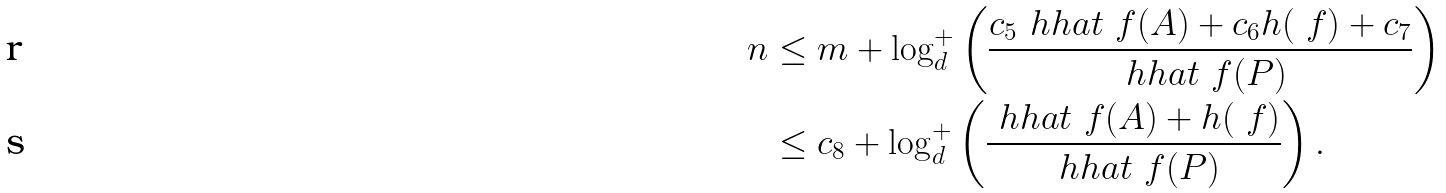Convert formula to latex. <formula><loc_0><loc_0><loc_500><loc_500>n & \leq m + \log _ { d } ^ { + } \left ( \frac { c _ { 5 } \ h h a t _ { \ } f ( A ) + c _ { 6 } h ( \ f ) + c _ { 7 } } { \ h h a t _ { \ } f ( P ) } \right ) \\ & \leq c _ { 8 } + \log _ { d } ^ { + } \left ( \frac { \ h h a t _ { \ } f ( A ) + h ( \ f ) } { \ h h a t _ { \ } f ( P ) } \right ) .</formula> 